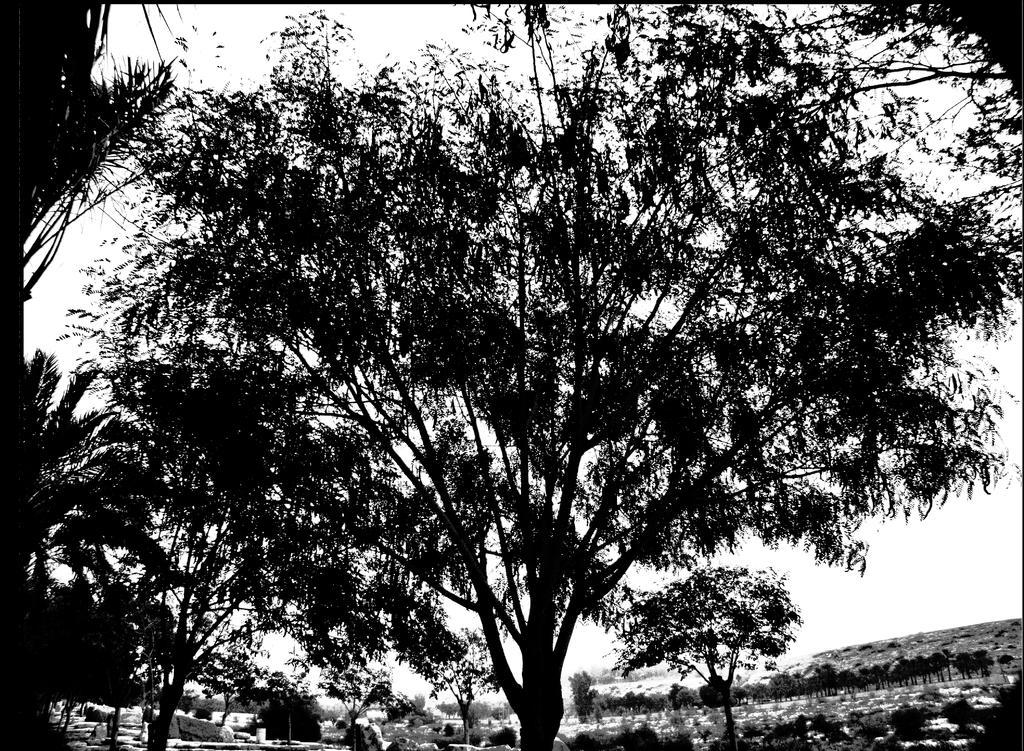Please provide a concise description of this image. This is black and white picture, in this picture we can see trees. In the background of the image we can see the sky. 